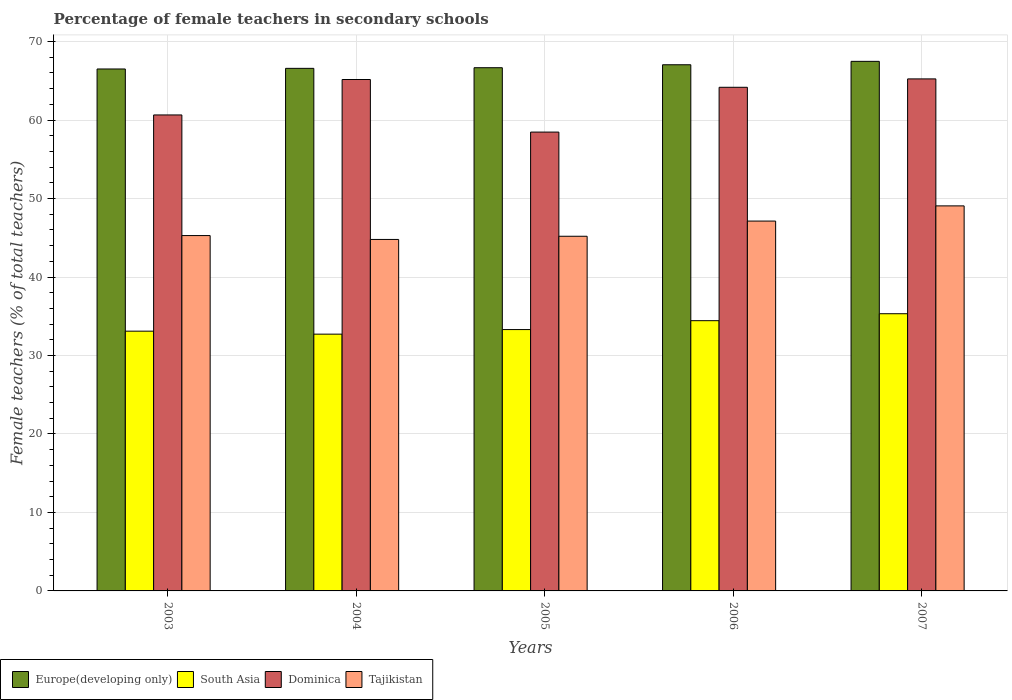In how many cases, is the number of bars for a given year not equal to the number of legend labels?
Provide a short and direct response. 0. What is the percentage of female teachers in Tajikistan in 2007?
Your response must be concise. 49.06. Across all years, what is the maximum percentage of female teachers in South Asia?
Your answer should be compact. 35.32. Across all years, what is the minimum percentage of female teachers in Dominica?
Your answer should be very brief. 58.47. In which year was the percentage of female teachers in Dominica maximum?
Ensure brevity in your answer.  2007. What is the total percentage of female teachers in South Asia in the graph?
Your response must be concise. 168.88. What is the difference between the percentage of female teachers in Dominica in 2004 and that in 2007?
Your response must be concise. -0.08. What is the difference between the percentage of female teachers in Tajikistan in 2005 and the percentage of female teachers in South Asia in 2003?
Provide a succinct answer. 12.09. What is the average percentage of female teachers in Tajikistan per year?
Make the answer very short. 46.29. In the year 2005, what is the difference between the percentage of female teachers in Dominica and percentage of female teachers in Tajikistan?
Your answer should be very brief. 13.27. In how many years, is the percentage of female teachers in South Asia greater than 2 %?
Your response must be concise. 5. What is the ratio of the percentage of female teachers in Dominica in 2003 to that in 2004?
Offer a terse response. 0.93. What is the difference between the highest and the second highest percentage of female teachers in Dominica?
Your response must be concise. 0.08. What is the difference between the highest and the lowest percentage of female teachers in Europe(developing only)?
Ensure brevity in your answer.  0.97. In how many years, is the percentage of female teachers in Europe(developing only) greater than the average percentage of female teachers in Europe(developing only) taken over all years?
Give a very brief answer. 2. Is the sum of the percentage of female teachers in Europe(developing only) in 2005 and 2007 greater than the maximum percentage of female teachers in Tajikistan across all years?
Ensure brevity in your answer.  Yes. What does the 4th bar from the left in 2007 represents?
Give a very brief answer. Tajikistan. What does the 4th bar from the right in 2007 represents?
Give a very brief answer. Europe(developing only). Are all the bars in the graph horizontal?
Keep it short and to the point. No. How many years are there in the graph?
Offer a terse response. 5. Does the graph contain any zero values?
Provide a short and direct response. No. Does the graph contain grids?
Make the answer very short. Yes. How many legend labels are there?
Offer a terse response. 4. What is the title of the graph?
Keep it short and to the point. Percentage of female teachers in secondary schools. What is the label or title of the Y-axis?
Make the answer very short. Female teachers (% of total teachers). What is the Female teachers (% of total teachers) of Europe(developing only) in 2003?
Your response must be concise. 66.51. What is the Female teachers (% of total teachers) of South Asia in 2003?
Your answer should be very brief. 33.1. What is the Female teachers (% of total teachers) of Dominica in 2003?
Provide a short and direct response. 60.65. What is the Female teachers (% of total teachers) of Tajikistan in 2003?
Offer a terse response. 45.28. What is the Female teachers (% of total teachers) in Europe(developing only) in 2004?
Your answer should be compact. 66.59. What is the Female teachers (% of total teachers) of South Asia in 2004?
Make the answer very short. 32.72. What is the Female teachers (% of total teachers) in Dominica in 2004?
Provide a succinct answer. 65.17. What is the Female teachers (% of total teachers) of Tajikistan in 2004?
Offer a very short reply. 44.79. What is the Female teachers (% of total teachers) in Europe(developing only) in 2005?
Provide a short and direct response. 66.67. What is the Female teachers (% of total teachers) in South Asia in 2005?
Your response must be concise. 33.3. What is the Female teachers (% of total teachers) in Dominica in 2005?
Make the answer very short. 58.47. What is the Female teachers (% of total teachers) of Tajikistan in 2005?
Your answer should be compact. 45.19. What is the Female teachers (% of total teachers) in Europe(developing only) in 2006?
Ensure brevity in your answer.  67.05. What is the Female teachers (% of total teachers) in South Asia in 2006?
Your response must be concise. 34.44. What is the Female teachers (% of total teachers) in Dominica in 2006?
Your response must be concise. 64.18. What is the Female teachers (% of total teachers) of Tajikistan in 2006?
Keep it short and to the point. 47.13. What is the Female teachers (% of total teachers) of Europe(developing only) in 2007?
Make the answer very short. 67.48. What is the Female teachers (% of total teachers) of South Asia in 2007?
Keep it short and to the point. 35.32. What is the Female teachers (% of total teachers) of Dominica in 2007?
Provide a succinct answer. 65.25. What is the Female teachers (% of total teachers) of Tajikistan in 2007?
Offer a very short reply. 49.06. Across all years, what is the maximum Female teachers (% of total teachers) of Europe(developing only)?
Ensure brevity in your answer.  67.48. Across all years, what is the maximum Female teachers (% of total teachers) in South Asia?
Provide a short and direct response. 35.32. Across all years, what is the maximum Female teachers (% of total teachers) of Dominica?
Your answer should be very brief. 65.25. Across all years, what is the maximum Female teachers (% of total teachers) of Tajikistan?
Your answer should be very brief. 49.06. Across all years, what is the minimum Female teachers (% of total teachers) in Europe(developing only)?
Ensure brevity in your answer.  66.51. Across all years, what is the minimum Female teachers (% of total teachers) in South Asia?
Ensure brevity in your answer.  32.72. Across all years, what is the minimum Female teachers (% of total teachers) of Dominica?
Provide a short and direct response. 58.47. Across all years, what is the minimum Female teachers (% of total teachers) in Tajikistan?
Provide a succinct answer. 44.79. What is the total Female teachers (% of total teachers) in Europe(developing only) in the graph?
Your response must be concise. 334.3. What is the total Female teachers (% of total teachers) of South Asia in the graph?
Provide a short and direct response. 168.88. What is the total Female teachers (% of total teachers) in Dominica in the graph?
Your answer should be very brief. 313.71. What is the total Female teachers (% of total teachers) of Tajikistan in the graph?
Your response must be concise. 231.45. What is the difference between the Female teachers (% of total teachers) of Europe(developing only) in 2003 and that in 2004?
Provide a short and direct response. -0.08. What is the difference between the Female teachers (% of total teachers) of South Asia in 2003 and that in 2004?
Provide a succinct answer. 0.38. What is the difference between the Female teachers (% of total teachers) in Dominica in 2003 and that in 2004?
Make the answer very short. -4.52. What is the difference between the Female teachers (% of total teachers) in Tajikistan in 2003 and that in 2004?
Your answer should be compact. 0.49. What is the difference between the Female teachers (% of total teachers) of Europe(developing only) in 2003 and that in 2005?
Give a very brief answer. -0.16. What is the difference between the Female teachers (% of total teachers) of South Asia in 2003 and that in 2005?
Keep it short and to the point. -0.2. What is the difference between the Female teachers (% of total teachers) in Dominica in 2003 and that in 2005?
Ensure brevity in your answer.  2.18. What is the difference between the Female teachers (% of total teachers) in Tajikistan in 2003 and that in 2005?
Give a very brief answer. 0.09. What is the difference between the Female teachers (% of total teachers) of Europe(developing only) in 2003 and that in 2006?
Offer a very short reply. -0.54. What is the difference between the Female teachers (% of total teachers) in South Asia in 2003 and that in 2006?
Your response must be concise. -1.34. What is the difference between the Female teachers (% of total teachers) of Dominica in 2003 and that in 2006?
Make the answer very short. -3.52. What is the difference between the Female teachers (% of total teachers) in Tajikistan in 2003 and that in 2006?
Your answer should be very brief. -1.85. What is the difference between the Female teachers (% of total teachers) in Europe(developing only) in 2003 and that in 2007?
Make the answer very short. -0.97. What is the difference between the Female teachers (% of total teachers) of South Asia in 2003 and that in 2007?
Keep it short and to the point. -2.22. What is the difference between the Female teachers (% of total teachers) in Dominica in 2003 and that in 2007?
Your answer should be compact. -4.59. What is the difference between the Female teachers (% of total teachers) of Tajikistan in 2003 and that in 2007?
Your answer should be compact. -3.78. What is the difference between the Female teachers (% of total teachers) in Europe(developing only) in 2004 and that in 2005?
Keep it short and to the point. -0.08. What is the difference between the Female teachers (% of total teachers) of South Asia in 2004 and that in 2005?
Ensure brevity in your answer.  -0.58. What is the difference between the Female teachers (% of total teachers) of Dominica in 2004 and that in 2005?
Ensure brevity in your answer.  6.7. What is the difference between the Female teachers (% of total teachers) of Tajikistan in 2004 and that in 2005?
Your answer should be compact. -0.41. What is the difference between the Female teachers (% of total teachers) of Europe(developing only) in 2004 and that in 2006?
Your answer should be compact. -0.46. What is the difference between the Female teachers (% of total teachers) in South Asia in 2004 and that in 2006?
Provide a short and direct response. -1.72. What is the difference between the Female teachers (% of total teachers) in Dominica in 2004 and that in 2006?
Make the answer very short. 0.99. What is the difference between the Female teachers (% of total teachers) in Tajikistan in 2004 and that in 2006?
Keep it short and to the point. -2.34. What is the difference between the Female teachers (% of total teachers) of Europe(developing only) in 2004 and that in 2007?
Keep it short and to the point. -0.89. What is the difference between the Female teachers (% of total teachers) in South Asia in 2004 and that in 2007?
Your response must be concise. -2.6. What is the difference between the Female teachers (% of total teachers) in Dominica in 2004 and that in 2007?
Provide a short and direct response. -0.08. What is the difference between the Female teachers (% of total teachers) in Tajikistan in 2004 and that in 2007?
Offer a terse response. -4.28. What is the difference between the Female teachers (% of total teachers) of Europe(developing only) in 2005 and that in 2006?
Offer a terse response. -0.38. What is the difference between the Female teachers (% of total teachers) of South Asia in 2005 and that in 2006?
Provide a short and direct response. -1.13. What is the difference between the Female teachers (% of total teachers) of Dominica in 2005 and that in 2006?
Provide a succinct answer. -5.71. What is the difference between the Female teachers (% of total teachers) in Tajikistan in 2005 and that in 2006?
Your response must be concise. -1.93. What is the difference between the Female teachers (% of total teachers) of Europe(developing only) in 2005 and that in 2007?
Offer a terse response. -0.81. What is the difference between the Female teachers (% of total teachers) of South Asia in 2005 and that in 2007?
Keep it short and to the point. -2.02. What is the difference between the Female teachers (% of total teachers) of Dominica in 2005 and that in 2007?
Give a very brief answer. -6.78. What is the difference between the Female teachers (% of total teachers) in Tajikistan in 2005 and that in 2007?
Your response must be concise. -3.87. What is the difference between the Female teachers (% of total teachers) in Europe(developing only) in 2006 and that in 2007?
Offer a very short reply. -0.43. What is the difference between the Female teachers (% of total teachers) of South Asia in 2006 and that in 2007?
Give a very brief answer. -0.89. What is the difference between the Female teachers (% of total teachers) in Dominica in 2006 and that in 2007?
Provide a succinct answer. -1.07. What is the difference between the Female teachers (% of total teachers) of Tajikistan in 2006 and that in 2007?
Keep it short and to the point. -1.94. What is the difference between the Female teachers (% of total teachers) in Europe(developing only) in 2003 and the Female teachers (% of total teachers) in South Asia in 2004?
Offer a terse response. 33.79. What is the difference between the Female teachers (% of total teachers) in Europe(developing only) in 2003 and the Female teachers (% of total teachers) in Dominica in 2004?
Offer a terse response. 1.34. What is the difference between the Female teachers (% of total teachers) in Europe(developing only) in 2003 and the Female teachers (% of total teachers) in Tajikistan in 2004?
Keep it short and to the point. 21.72. What is the difference between the Female teachers (% of total teachers) in South Asia in 2003 and the Female teachers (% of total teachers) in Dominica in 2004?
Your response must be concise. -32.07. What is the difference between the Female teachers (% of total teachers) in South Asia in 2003 and the Female teachers (% of total teachers) in Tajikistan in 2004?
Offer a terse response. -11.69. What is the difference between the Female teachers (% of total teachers) of Dominica in 2003 and the Female teachers (% of total teachers) of Tajikistan in 2004?
Offer a very short reply. 15.87. What is the difference between the Female teachers (% of total teachers) of Europe(developing only) in 2003 and the Female teachers (% of total teachers) of South Asia in 2005?
Provide a short and direct response. 33.21. What is the difference between the Female teachers (% of total teachers) in Europe(developing only) in 2003 and the Female teachers (% of total teachers) in Dominica in 2005?
Keep it short and to the point. 8.04. What is the difference between the Female teachers (% of total teachers) in Europe(developing only) in 2003 and the Female teachers (% of total teachers) in Tajikistan in 2005?
Ensure brevity in your answer.  21.32. What is the difference between the Female teachers (% of total teachers) of South Asia in 2003 and the Female teachers (% of total teachers) of Dominica in 2005?
Your answer should be compact. -25.37. What is the difference between the Female teachers (% of total teachers) in South Asia in 2003 and the Female teachers (% of total teachers) in Tajikistan in 2005?
Provide a succinct answer. -12.09. What is the difference between the Female teachers (% of total teachers) in Dominica in 2003 and the Female teachers (% of total teachers) in Tajikistan in 2005?
Offer a terse response. 15.46. What is the difference between the Female teachers (% of total teachers) in Europe(developing only) in 2003 and the Female teachers (% of total teachers) in South Asia in 2006?
Your answer should be very brief. 32.07. What is the difference between the Female teachers (% of total teachers) in Europe(developing only) in 2003 and the Female teachers (% of total teachers) in Dominica in 2006?
Offer a terse response. 2.33. What is the difference between the Female teachers (% of total teachers) in Europe(developing only) in 2003 and the Female teachers (% of total teachers) in Tajikistan in 2006?
Offer a very short reply. 19.38. What is the difference between the Female teachers (% of total teachers) in South Asia in 2003 and the Female teachers (% of total teachers) in Dominica in 2006?
Provide a short and direct response. -31.08. What is the difference between the Female teachers (% of total teachers) in South Asia in 2003 and the Female teachers (% of total teachers) in Tajikistan in 2006?
Ensure brevity in your answer.  -14.03. What is the difference between the Female teachers (% of total teachers) of Dominica in 2003 and the Female teachers (% of total teachers) of Tajikistan in 2006?
Ensure brevity in your answer.  13.52. What is the difference between the Female teachers (% of total teachers) in Europe(developing only) in 2003 and the Female teachers (% of total teachers) in South Asia in 2007?
Ensure brevity in your answer.  31.19. What is the difference between the Female teachers (% of total teachers) of Europe(developing only) in 2003 and the Female teachers (% of total teachers) of Dominica in 2007?
Provide a short and direct response. 1.26. What is the difference between the Female teachers (% of total teachers) of Europe(developing only) in 2003 and the Female teachers (% of total teachers) of Tajikistan in 2007?
Give a very brief answer. 17.45. What is the difference between the Female teachers (% of total teachers) of South Asia in 2003 and the Female teachers (% of total teachers) of Dominica in 2007?
Keep it short and to the point. -32.14. What is the difference between the Female teachers (% of total teachers) in South Asia in 2003 and the Female teachers (% of total teachers) in Tajikistan in 2007?
Your answer should be compact. -15.96. What is the difference between the Female teachers (% of total teachers) in Dominica in 2003 and the Female teachers (% of total teachers) in Tajikistan in 2007?
Offer a very short reply. 11.59. What is the difference between the Female teachers (% of total teachers) of Europe(developing only) in 2004 and the Female teachers (% of total teachers) of South Asia in 2005?
Offer a very short reply. 33.29. What is the difference between the Female teachers (% of total teachers) in Europe(developing only) in 2004 and the Female teachers (% of total teachers) in Dominica in 2005?
Your answer should be very brief. 8.12. What is the difference between the Female teachers (% of total teachers) in Europe(developing only) in 2004 and the Female teachers (% of total teachers) in Tajikistan in 2005?
Give a very brief answer. 21.4. What is the difference between the Female teachers (% of total teachers) of South Asia in 2004 and the Female teachers (% of total teachers) of Dominica in 2005?
Give a very brief answer. -25.75. What is the difference between the Female teachers (% of total teachers) in South Asia in 2004 and the Female teachers (% of total teachers) in Tajikistan in 2005?
Your response must be concise. -12.47. What is the difference between the Female teachers (% of total teachers) in Dominica in 2004 and the Female teachers (% of total teachers) in Tajikistan in 2005?
Offer a very short reply. 19.97. What is the difference between the Female teachers (% of total teachers) of Europe(developing only) in 2004 and the Female teachers (% of total teachers) of South Asia in 2006?
Provide a short and direct response. 32.15. What is the difference between the Female teachers (% of total teachers) in Europe(developing only) in 2004 and the Female teachers (% of total teachers) in Dominica in 2006?
Offer a very short reply. 2.41. What is the difference between the Female teachers (% of total teachers) of Europe(developing only) in 2004 and the Female teachers (% of total teachers) of Tajikistan in 2006?
Provide a succinct answer. 19.46. What is the difference between the Female teachers (% of total teachers) of South Asia in 2004 and the Female teachers (% of total teachers) of Dominica in 2006?
Your answer should be very brief. -31.46. What is the difference between the Female teachers (% of total teachers) of South Asia in 2004 and the Female teachers (% of total teachers) of Tajikistan in 2006?
Offer a terse response. -14.41. What is the difference between the Female teachers (% of total teachers) in Dominica in 2004 and the Female teachers (% of total teachers) in Tajikistan in 2006?
Provide a short and direct response. 18.04. What is the difference between the Female teachers (% of total teachers) of Europe(developing only) in 2004 and the Female teachers (% of total teachers) of South Asia in 2007?
Offer a very short reply. 31.27. What is the difference between the Female teachers (% of total teachers) in Europe(developing only) in 2004 and the Female teachers (% of total teachers) in Dominica in 2007?
Your answer should be compact. 1.34. What is the difference between the Female teachers (% of total teachers) of Europe(developing only) in 2004 and the Female teachers (% of total teachers) of Tajikistan in 2007?
Your answer should be very brief. 17.53. What is the difference between the Female teachers (% of total teachers) of South Asia in 2004 and the Female teachers (% of total teachers) of Dominica in 2007?
Provide a short and direct response. -32.53. What is the difference between the Female teachers (% of total teachers) of South Asia in 2004 and the Female teachers (% of total teachers) of Tajikistan in 2007?
Provide a short and direct response. -16.34. What is the difference between the Female teachers (% of total teachers) of Dominica in 2004 and the Female teachers (% of total teachers) of Tajikistan in 2007?
Provide a succinct answer. 16.11. What is the difference between the Female teachers (% of total teachers) in Europe(developing only) in 2005 and the Female teachers (% of total teachers) in South Asia in 2006?
Ensure brevity in your answer.  32.23. What is the difference between the Female teachers (% of total teachers) of Europe(developing only) in 2005 and the Female teachers (% of total teachers) of Dominica in 2006?
Provide a short and direct response. 2.49. What is the difference between the Female teachers (% of total teachers) in Europe(developing only) in 2005 and the Female teachers (% of total teachers) in Tajikistan in 2006?
Make the answer very short. 19.54. What is the difference between the Female teachers (% of total teachers) in South Asia in 2005 and the Female teachers (% of total teachers) in Dominica in 2006?
Ensure brevity in your answer.  -30.87. What is the difference between the Female teachers (% of total teachers) of South Asia in 2005 and the Female teachers (% of total teachers) of Tajikistan in 2006?
Provide a short and direct response. -13.82. What is the difference between the Female teachers (% of total teachers) of Dominica in 2005 and the Female teachers (% of total teachers) of Tajikistan in 2006?
Keep it short and to the point. 11.34. What is the difference between the Female teachers (% of total teachers) of Europe(developing only) in 2005 and the Female teachers (% of total teachers) of South Asia in 2007?
Ensure brevity in your answer.  31.35. What is the difference between the Female teachers (% of total teachers) in Europe(developing only) in 2005 and the Female teachers (% of total teachers) in Dominica in 2007?
Your response must be concise. 1.42. What is the difference between the Female teachers (% of total teachers) in Europe(developing only) in 2005 and the Female teachers (% of total teachers) in Tajikistan in 2007?
Ensure brevity in your answer.  17.61. What is the difference between the Female teachers (% of total teachers) of South Asia in 2005 and the Female teachers (% of total teachers) of Dominica in 2007?
Your answer should be compact. -31.94. What is the difference between the Female teachers (% of total teachers) of South Asia in 2005 and the Female teachers (% of total teachers) of Tajikistan in 2007?
Provide a succinct answer. -15.76. What is the difference between the Female teachers (% of total teachers) of Dominica in 2005 and the Female teachers (% of total teachers) of Tajikistan in 2007?
Ensure brevity in your answer.  9.4. What is the difference between the Female teachers (% of total teachers) of Europe(developing only) in 2006 and the Female teachers (% of total teachers) of South Asia in 2007?
Ensure brevity in your answer.  31.72. What is the difference between the Female teachers (% of total teachers) in Europe(developing only) in 2006 and the Female teachers (% of total teachers) in Dominica in 2007?
Provide a short and direct response. 1.8. What is the difference between the Female teachers (% of total teachers) in Europe(developing only) in 2006 and the Female teachers (% of total teachers) in Tajikistan in 2007?
Your response must be concise. 17.98. What is the difference between the Female teachers (% of total teachers) in South Asia in 2006 and the Female teachers (% of total teachers) in Dominica in 2007?
Your response must be concise. -30.81. What is the difference between the Female teachers (% of total teachers) in South Asia in 2006 and the Female teachers (% of total teachers) in Tajikistan in 2007?
Provide a short and direct response. -14.63. What is the difference between the Female teachers (% of total teachers) in Dominica in 2006 and the Female teachers (% of total teachers) in Tajikistan in 2007?
Keep it short and to the point. 15.11. What is the average Female teachers (% of total teachers) in Europe(developing only) per year?
Give a very brief answer. 66.86. What is the average Female teachers (% of total teachers) in South Asia per year?
Ensure brevity in your answer.  33.78. What is the average Female teachers (% of total teachers) of Dominica per year?
Give a very brief answer. 62.74. What is the average Female teachers (% of total teachers) in Tajikistan per year?
Give a very brief answer. 46.29. In the year 2003, what is the difference between the Female teachers (% of total teachers) in Europe(developing only) and Female teachers (% of total teachers) in South Asia?
Offer a terse response. 33.41. In the year 2003, what is the difference between the Female teachers (% of total teachers) of Europe(developing only) and Female teachers (% of total teachers) of Dominica?
Your answer should be compact. 5.86. In the year 2003, what is the difference between the Female teachers (% of total teachers) in Europe(developing only) and Female teachers (% of total teachers) in Tajikistan?
Your answer should be compact. 21.23. In the year 2003, what is the difference between the Female teachers (% of total teachers) of South Asia and Female teachers (% of total teachers) of Dominica?
Provide a short and direct response. -27.55. In the year 2003, what is the difference between the Female teachers (% of total teachers) of South Asia and Female teachers (% of total teachers) of Tajikistan?
Keep it short and to the point. -12.18. In the year 2003, what is the difference between the Female teachers (% of total teachers) in Dominica and Female teachers (% of total teachers) in Tajikistan?
Give a very brief answer. 15.37. In the year 2004, what is the difference between the Female teachers (% of total teachers) in Europe(developing only) and Female teachers (% of total teachers) in South Asia?
Your answer should be compact. 33.87. In the year 2004, what is the difference between the Female teachers (% of total teachers) of Europe(developing only) and Female teachers (% of total teachers) of Dominica?
Provide a succinct answer. 1.42. In the year 2004, what is the difference between the Female teachers (% of total teachers) in Europe(developing only) and Female teachers (% of total teachers) in Tajikistan?
Offer a terse response. 21.8. In the year 2004, what is the difference between the Female teachers (% of total teachers) in South Asia and Female teachers (% of total teachers) in Dominica?
Your answer should be compact. -32.45. In the year 2004, what is the difference between the Female teachers (% of total teachers) of South Asia and Female teachers (% of total teachers) of Tajikistan?
Make the answer very short. -12.07. In the year 2004, what is the difference between the Female teachers (% of total teachers) in Dominica and Female teachers (% of total teachers) in Tajikistan?
Give a very brief answer. 20.38. In the year 2005, what is the difference between the Female teachers (% of total teachers) of Europe(developing only) and Female teachers (% of total teachers) of South Asia?
Keep it short and to the point. 33.37. In the year 2005, what is the difference between the Female teachers (% of total teachers) in Europe(developing only) and Female teachers (% of total teachers) in Dominica?
Keep it short and to the point. 8.2. In the year 2005, what is the difference between the Female teachers (% of total teachers) of Europe(developing only) and Female teachers (% of total teachers) of Tajikistan?
Make the answer very short. 21.48. In the year 2005, what is the difference between the Female teachers (% of total teachers) of South Asia and Female teachers (% of total teachers) of Dominica?
Ensure brevity in your answer.  -25.16. In the year 2005, what is the difference between the Female teachers (% of total teachers) in South Asia and Female teachers (% of total teachers) in Tajikistan?
Provide a succinct answer. -11.89. In the year 2005, what is the difference between the Female teachers (% of total teachers) in Dominica and Female teachers (% of total teachers) in Tajikistan?
Provide a short and direct response. 13.27. In the year 2006, what is the difference between the Female teachers (% of total teachers) of Europe(developing only) and Female teachers (% of total teachers) of South Asia?
Provide a succinct answer. 32.61. In the year 2006, what is the difference between the Female teachers (% of total teachers) of Europe(developing only) and Female teachers (% of total teachers) of Dominica?
Your answer should be compact. 2.87. In the year 2006, what is the difference between the Female teachers (% of total teachers) of Europe(developing only) and Female teachers (% of total teachers) of Tajikistan?
Your answer should be very brief. 19.92. In the year 2006, what is the difference between the Female teachers (% of total teachers) in South Asia and Female teachers (% of total teachers) in Dominica?
Keep it short and to the point. -29.74. In the year 2006, what is the difference between the Female teachers (% of total teachers) in South Asia and Female teachers (% of total teachers) in Tajikistan?
Ensure brevity in your answer.  -12.69. In the year 2006, what is the difference between the Female teachers (% of total teachers) in Dominica and Female teachers (% of total teachers) in Tajikistan?
Keep it short and to the point. 17.05. In the year 2007, what is the difference between the Female teachers (% of total teachers) in Europe(developing only) and Female teachers (% of total teachers) in South Asia?
Offer a very short reply. 32.16. In the year 2007, what is the difference between the Female teachers (% of total teachers) in Europe(developing only) and Female teachers (% of total teachers) in Dominica?
Keep it short and to the point. 2.24. In the year 2007, what is the difference between the Female teachers (% of total teachers) in Europe(developing only) and Female teachers (% of total teachers) in Tajikistan?
Offer a very short reply. 18.42. In the year 2007, what is the difference between the Female teachers (% of total teachers) of South Asia and Female teachers (% of total teachers) of Dominica?
Offer a terse response. -29.92. In the year 2007, what is the difference between the Female teachers (% of total teachers) of South Asia and Female teachers (% of total teachers) of Tajikistan?
Provide a succinct answer. -13.74. In the year 2007, what is the difference between the Female teachers (% of total teachers) in Dominica and Female teachers (% of total teachers) in Tajikistan?
Your answer should be compact. 16.18. What is the ratio of the Female teachers (% of total teachers) in South Asia in 2003 to that in 2004?
Offer a very short reply. 1.01. What is the ratio of the Female teachers (% of total teachers) of Dominica in 2003 to that in 2004?
Your answer should be compact. 0.93. What is the ratio of the Female teachers (% of total teachers) of Tajikistan in 2003 to that in 2004?
Offer a very short reply. 1.01. What is the ratio of the Female teachers (% of total teachers) in Europe(developing only) in 2003 to that in 2005?
Offer a terse response. 1. What is the ratio of the Female teachers (% of total teachers) in Dominica in 2003 to that in 2005?
Give a very brief answer. 1.04. What is the ratio of the Female teachers (% of total teachers) in Tajikistan in 2003 to that in 2005?
Provide a succinct answer. 1. What is the ratio of the Female teachers (% of total teachers) in Europe(developing only) in 2003 to that in 2006?
Offer a terse response. 0.99. What is the ratio of the Female teachers (% of total teachers) in South Asia in 2003 to that in 2006?
Your answer should be compact. 0.96. What is the ratio of the Female teachers (% of total teachers) in Dominica in 2003 to that in 2006?
Keep it short and to the point. 0.95. What is the ratio of the Female teachers (% of total teachers) in Tajikistan in 2003 to that in 2006?
Offer a very short reply. 0.96. What is the ratio of the Female teachers (% of total teachers) in Europe(developing only) in 2003 to that in 2007?
Provide a short and direct response. 0.99. What is the ratio of the Female teachers (% of total teachers) of South Asia in 2003 to that in 2007?
Make the answer very short. 0.94. What is the ratio of the Female teachers (% of total teachers) in Dominica in 2003 to that in 2007?
Offer a terse response. 0.93. What is the ratio of the Female teachers (% of total teachers) in Tajikistan in 2003 to that in 2007?
Provide a succinct answer. 0.92. What is the ratio of the Female teachers (% of total teachers) of Europe(developing only) in 2004 to that in 2005?
Ensure brevity in your answer.  1. What is the ratio of the Female teachers (% of total teachers) of South Asia in 2004 to that in 2005?
Offer a terse response. 0.98. What is the ratio of the Female teachers (% of total teachers) in Dominica in 2004 to that in 2005?
Your answer should be very brief. 1.11. What is the ratio of the Female teachers (% of total teachers) in Europe(developing only) in 2004 to that in 2006?
Your answer should be compact. 0.99. What is the ratio of the Female teachers (% of total teachers) of South Asia in 2004 to that in 2006?
Make the answer very short. 0.95. What is the ratio of the Female teachers (% of total teachers) of Dominica in 2004 to that in 2006?
Give a very brief answer. 1.02. What is the ratio of the Female teachers (% of total teachers) of Tajikistan in 2004 to that in 2006?
Offer a terse response. 0.95. What is the ratio of the Female teachers (% of total teachers) of South Asia in 2004 to that in 2007?
Keep it short and to the point. 0.93. What is the ratio of the Female teachers (% of total teachers) of Tajikistan in 2004 to that in 2007?
Ensure brevity in your answer.  0.91. What is the ratio of the Female teachers (% of total teachers) of Europe(developing only) in 2005 to that in 2006?
Your answer should be compact. 0.99. What is the ratio of the Female teachers (% of total teachers) in South Asia in 2005 to that in 2006?
Provide a succinct answer. 0.97. What is the ratio of the Female teachers (% of total teachers) of Dominica in 2005 to that in 2006?
Your answer should be very brief. 0.91. What is the ratio of the Female teachers (% of total teachers) of Tajikistan in 2005 to that in 2006?
Your response must be concise. 0.96. What is the ratio of the Female teachers (% of total teachers) of Europe(developing only) in 2005 to that in 2007?
Offer a very short reply. 0.99. What is the ratio of the Female teachers (% of total teachers) in South Asia in 2005 to that in 2007?
Keep it short and to the point. 0.94. What is the ratio of the Female teachers (% of total teachers) in Dominica in 2005 to that in 2007?
Your answer should be very brief. 0.9. What is the ratio of the Female teachers (% of total teachers) in Tajikistan in 2005 to that in 2007?
Ensure brevity in your answer.  0.92. What is the ratio of the Female teachers (% of total teachers) in Europe(developing only) in 2006 to that in 2007?
Give a very brief answer. 0.99. What is the ratio of the Female teachers (% of total teachers) in South Asia in 2006 to that in 2007?
Give a very brief answer. 0.97. What is the ratio of the Female teachers (% of total teachers) in Dominica in 2006 to that in 2007?
Keep it short and to the point. 0.98. What is the ratio of the Female teachers (% of total teachers) of Tajikistan in 2006 to that in 2007?
Offer a very short reply. 0.96. What is the difference between the highest and the second highest Female teachers (% of total teachers) in Europe(developing only)?
Keep it short and to the point. 0.43. What is the difference between the highest and the second highest Female teachers (% of total teachers) in South Asia?
Your response must be concise. 0.89. What is the difference between the highest and the second highest Female teachers (% of total teachers) of Dominica?
Your response must be concise. 0.08. What is the difference between the highest and the second highest Female teachers (% of total teachers) in Tajikistan?
Offer a terse response. 1.94. What is the difference between the highest and the lowest Female teachers (% of total teachers) of Europe(developing only)?
Your answer should be compact. 0.97. What is the difference between the highest and the lowest Female teachers (% of total teachers) in South Asia?
Keep it short and to the point. 2.6. What is the difference between the highest and the lowest Female teachers (% of total teachers) in Dominica?
Provide a short and direct response. 6.78. What is the difference between the highest and the lowest Female teachers (% of total teachers) of Tajikistan?
Give a very brief answer. 4.28. 